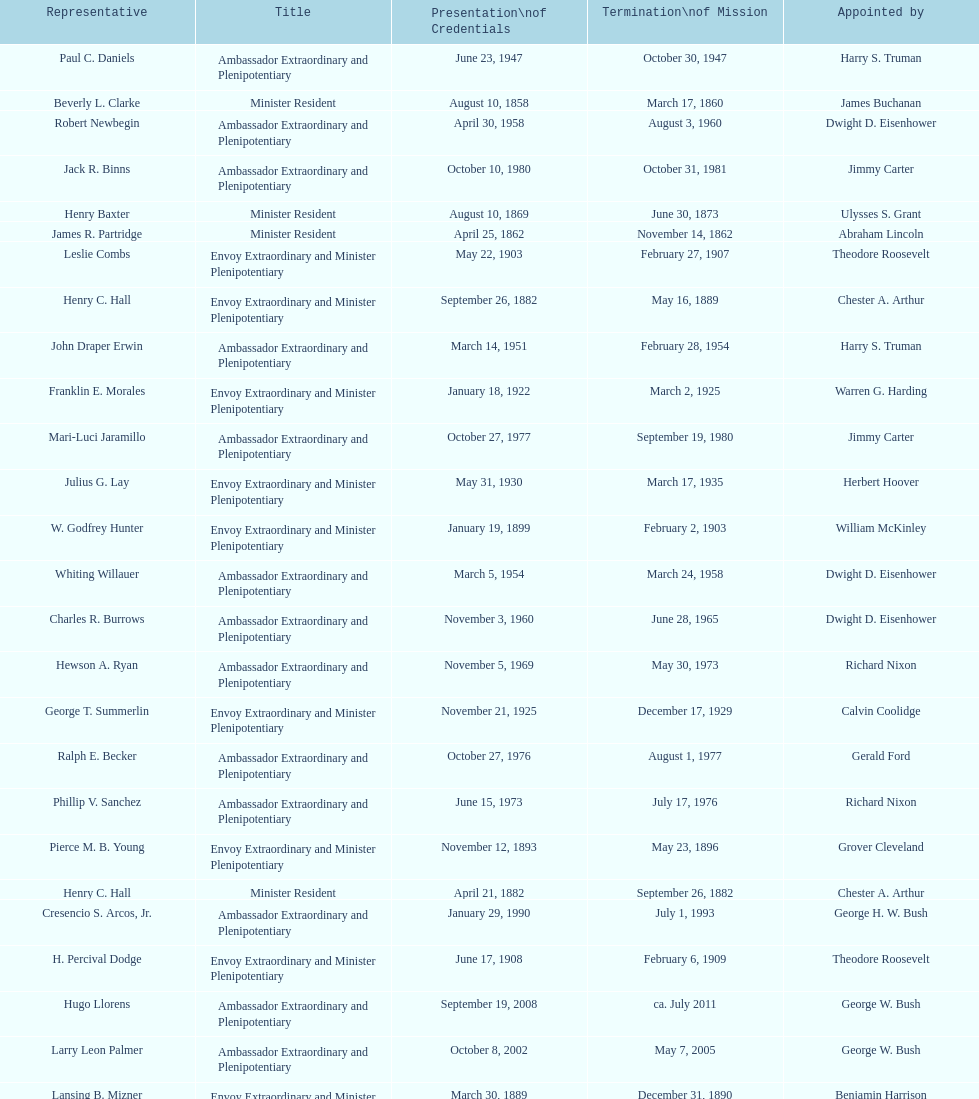What was the length, in years, of leslie combs' term? 4 years. 